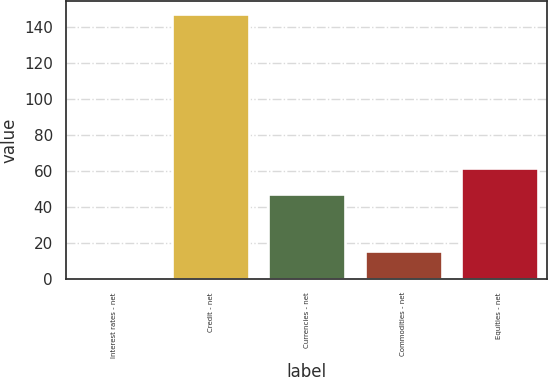<chart> <loc_0><loc_0><loc_500><loc_500><bar_chart><fcel>Interest rates - net<fcel>Credit - net<fcel>Currencies - net<fcel>Commodities - net<fcel>Equities - net<nl><fcel>1<fcel>147<fcel>47<fcel>15.6<fcel>61.6<nl></chart> 